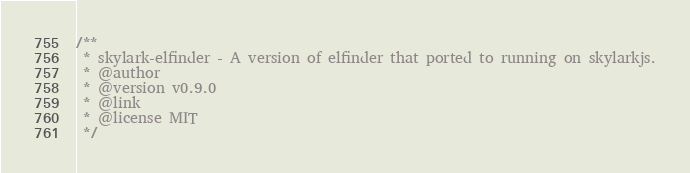Convert code to text. <code><loc_0><loc_0><loc_500><loc_500><_JavaScript_>/**
 * skylark-elfinder - A version of elfinder that ported to running on skylarkjs.
 * @author 
 * @version v0.9.0
 * @link 
 * @license MIT
 */</code> 